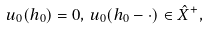<formula> <loc_0><loc_0><loc_500><loc_500>u _ { 0 } ( h _ { 0 } ) = 0 , \, u _ { 0 } ( h _ { 0 } - \cdot ) \in \hat { X } ^ { + } ,</formula> 